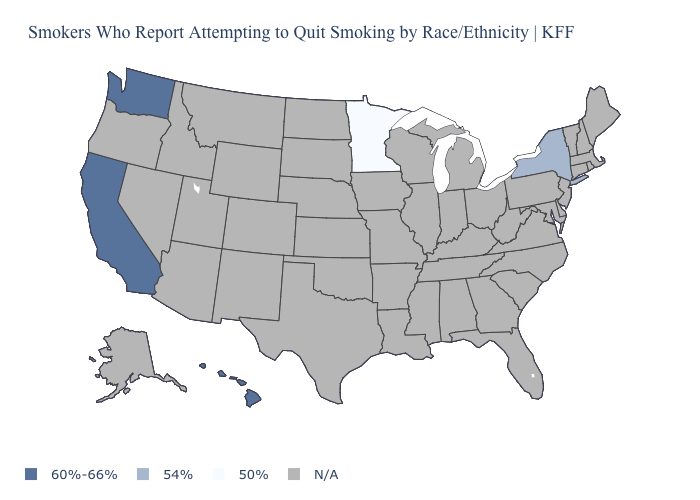Which states hav the highest value in the West?
Write a very short answer. California, Hawaii, Washington. Among the states that border Arizona , which have the lowest value?
Answer briefly. California. What is the value of Indiana?
Give a very brief answer. N/A. Which states have the lowest value in the MidWest?
Answer briefly. Minnesota. Name the states that have a value in the range 50%?
Give a very brief answer. Minnesota. Name the states that have a value in the range N/A?
Give a very brief answer. Alabama, Alaska, Arizona, Arkansas, Colorado, Connecticut, Delaware, Florida, Georgia, Idaho, Illinois, Indiana, Iowa, Kansas, Kentucky, Louisiana, Maine, Maryland, Massachusetts, Michigan, Mississippi, Missouri, Montana, Nebraska, Nevada, New Hampshire, New Jersey, New Mexico, North Carolina, North Dakota, Ohio, Oklahoma, Oregon, Pennsylvania, Rhode Island, South Carolina, South Dakota, Tennessee, Texas, Utah, Vermont, Virginia, West Virginia, Wisconsin, Wyoming. Name the states that have a value in the range 54%?
Be succinct. New York. Name the states that have a value in the range 50%?
Write a very short answer. Minnesota. What is the value of Kentucky?
Short answer required. N/A. What is the value of Oklahoma?
Quick response, please. N/A. Does Minnesota have the highest value in the USA?
Concise answer only. No. 